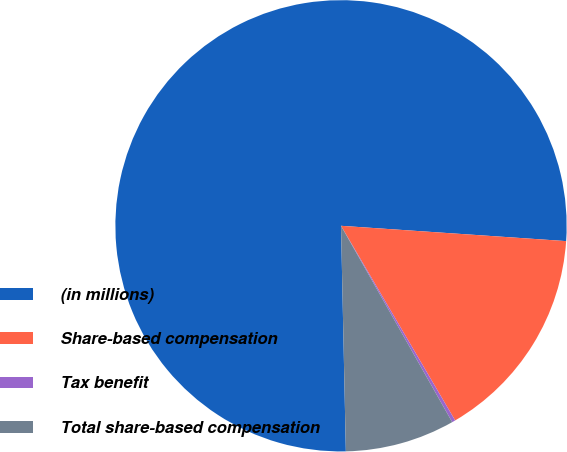<chart> <loc_0><loc_0><loc_500><loc_500><pie_chart><fcel>(in millions)<fcel>Share-based compensation<fcel>Tax benefit<fcel>Total share-based compensation<nl><fcel>76.43%<fcel>15.48%<fcel>0.24%<fcel>7.86%<nl></chart> 